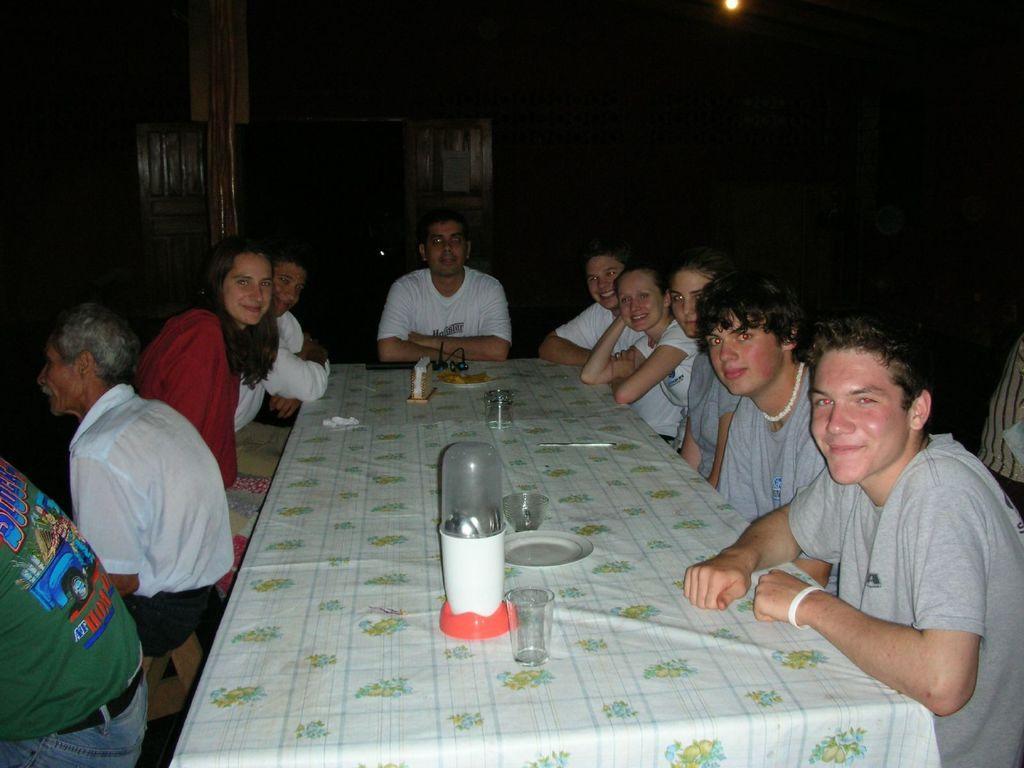Could you give a brief overview of what you see in this image? Background is very dark. This is alight at the top of the picture. Here we can see few persons sitting on chairs in front of a table and they all hold a smile on their faces. Here on the table we can see plate, glasses, tissue paper stand and a bottle of spoons. At the left side of the picture we can see two men sitting on chairs facing their back. 